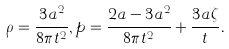<formula> <loc_0><loc_0><loc_500><loc_500>\rho = \frac { 3 a ^ { 2 } } { 8 \pi t ^ { 2 } } , p = \frac { 2 a - 3 a ^ { 2 } } { 8 \pi t ^ { 2 } } + \frac { 3 a \zeta } { t } .</formula> 